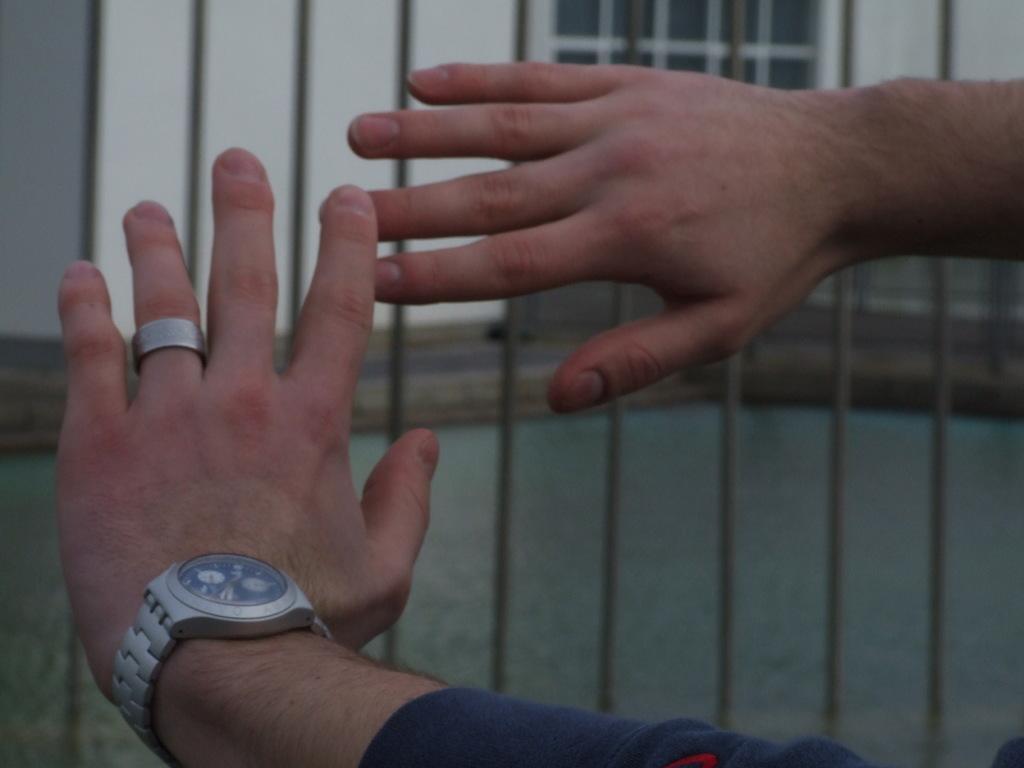Could you give a brief overview of what you see in this image? Here we can see hands of a person and there is a watch. In the background we can see a fence and a wall. 